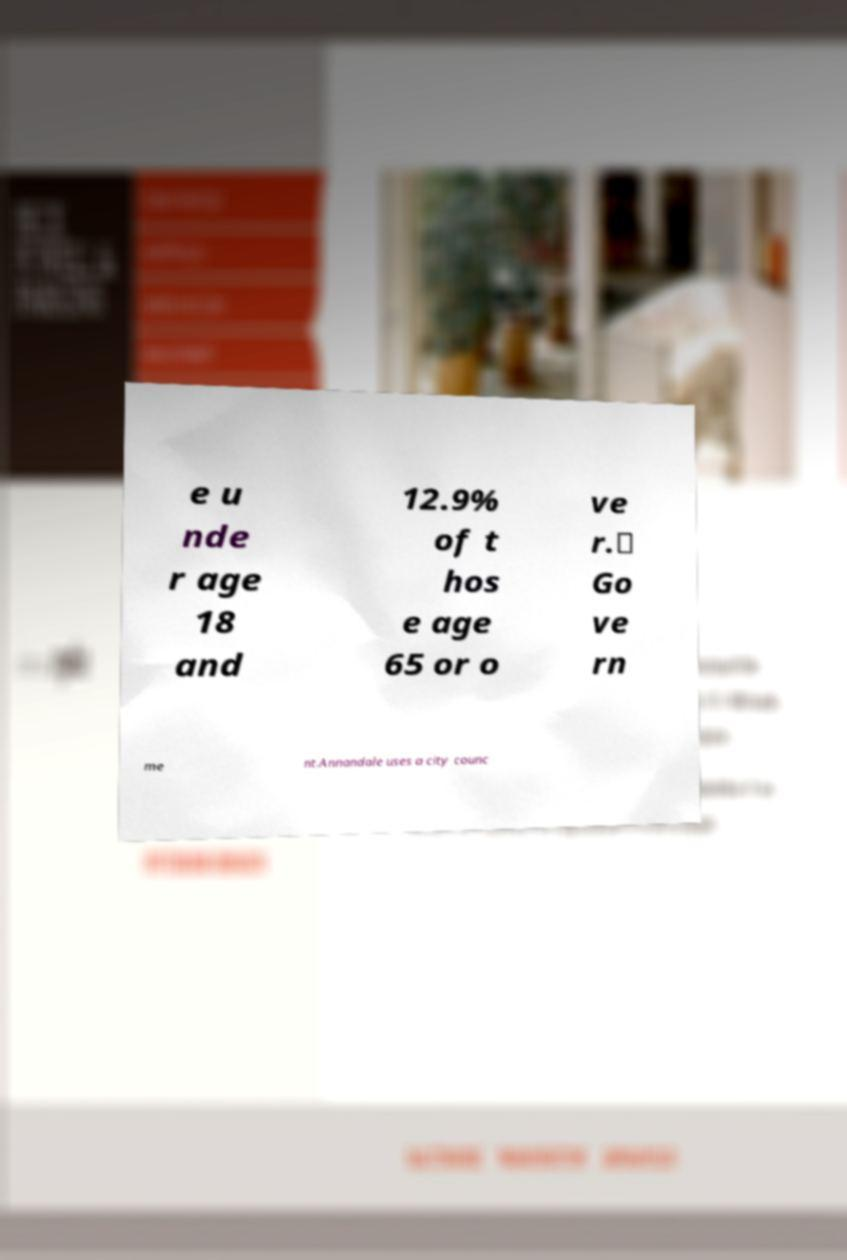Could you assist in decoding the text presented in this image and type it out clearly? e u nde r age 18 and 12.9% of t hos e age 65 or o ve r.\ Go ve rn me nt.Annandale uses a city counc 